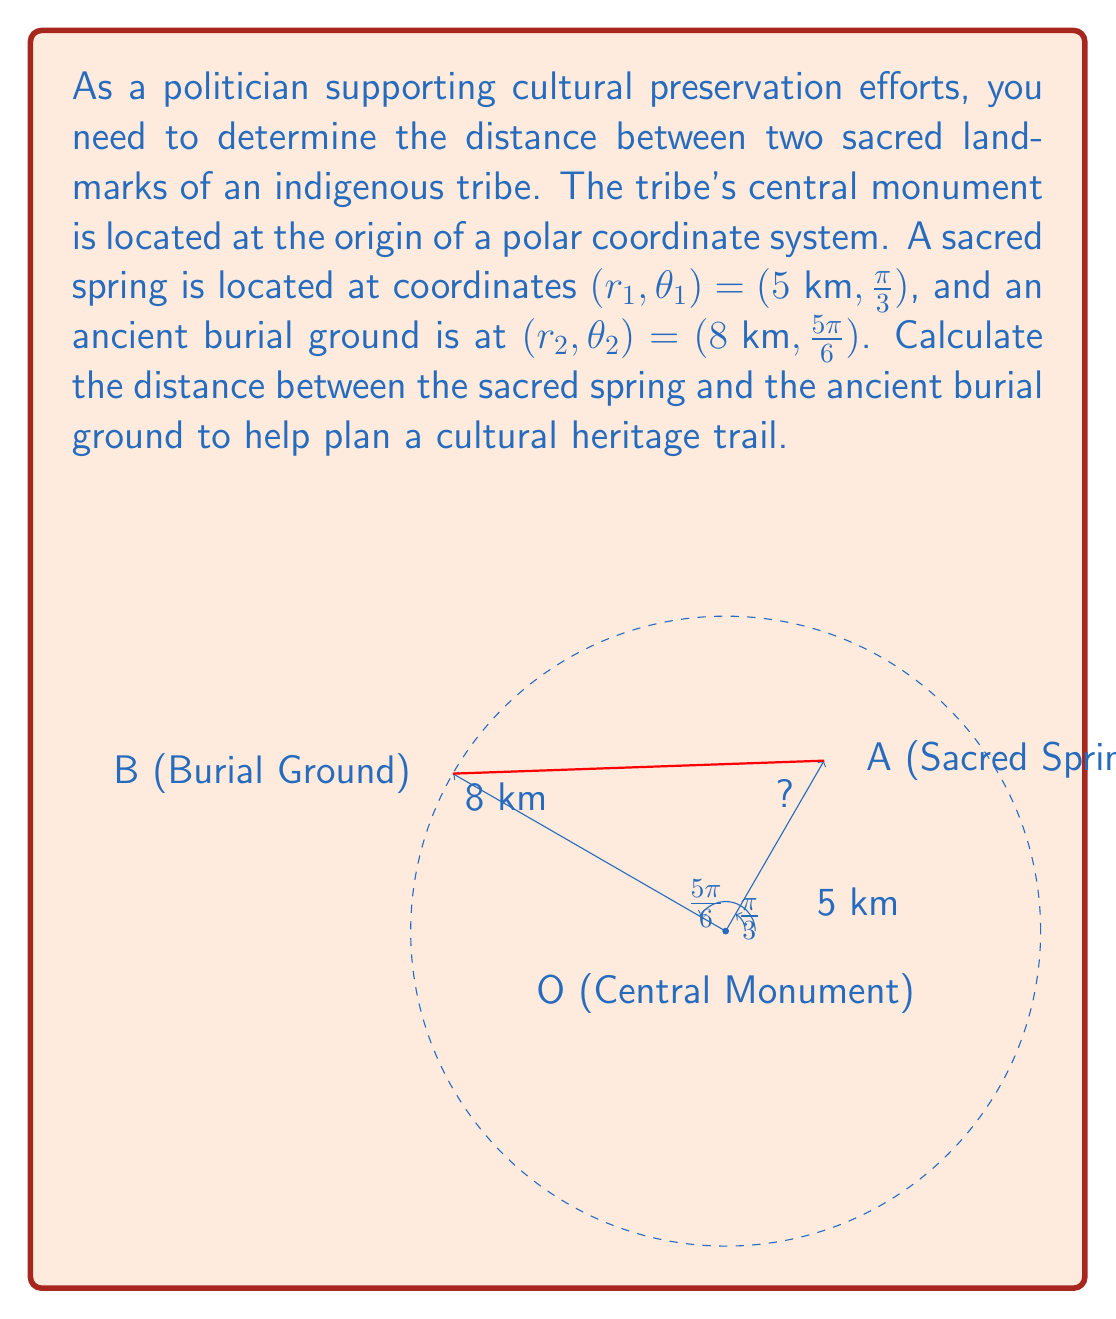Help me with this question. To find the distance between two points in polar coordinates, we can use the polar form of the distance formula:

$$d = \sqrt{r_1^2 + r_2^2 - 2r_1r_2 \cos(\theta_2 - \theta_1)}$$

Where:
- $r_1 = 5$ km (distance of sacred spring from origin)
- $r_2 = 8$ km (distance of burial ground from origin)
- $\theta_1 = \frac{\pi}{3}$ (angle of sacred spring)
- $\theta_2 = \frac{5\pi}{6}$ (angle of burial ground)

Step 1: Calculate $\theta_2 - \theta_1$
$$\theta_2 - \theta_1 = \frac{5\pi}{6} - \frac{\pi}{3} = \frac{5\pi}{6} - \frac{2\pi}{6} = \frac{\pi}{2}$$

Step 2: Calculate $\cos(\theta_2 - \theta_1)$
$$\cos(\frac{\pi}{2}) = 0$$

Step 3: Substitute values into the distance formula
$$d = \sqrt{5^2 + 8^2 - 2(5)(8) \cos(\frac{\pi}{2})}$$

Step 4: Simplify
$$d = \sqrt{25 + 64 - 2(40)(0)}$$
$$d = \sqrt{89}$$

Step 5: Simplify the square root
$$d = \sqrt{89} \approx 9.43 \text{ km}$$
Answer: $\sqrt{89} \approx 9.43 \text{ km}$ 